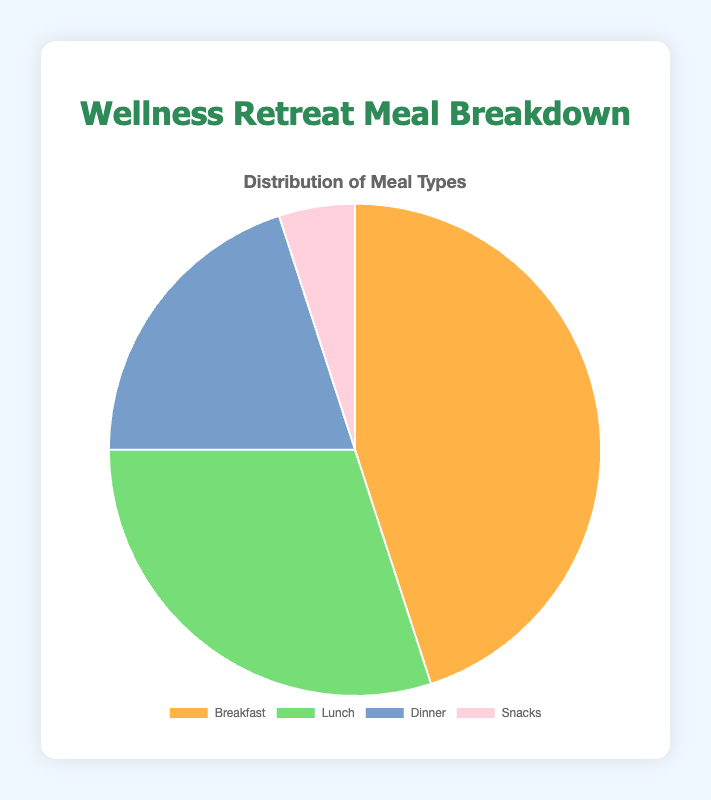What percentage of meals served are either for lunch or dinner? To find this, add the counts for Lunch (30) and Dinner (20), making 50. The total number of meals is 100. Therefore, the percentage is (50/100) * 100 = 50%.
Answer: 50% Which meal type is served the most frequently? The pie chart indicates that Breakfast has the highest count, which is 45. Comparing the numbers, Breakfast is the highest among all meal types.
Answer: Breakfast How many more breakfast meals are served compared to snack meals? The count for Breakfast is 45 and for Snacks is 5. Subtracting these: 45 - 5 = 40.
Answer: 40 What is the ratio of breakfast meals to dinner meals? The count for Breakfast is 45 and for Dinner is 20. The ratio is 45:20 or simplified to 9:4.
Answer: 9:4 Which meal type makes up exactly one-fifth of the total meals served? One-fifth of the total meals (100) is 20. The count for Dinner precisely matches this value, so Dinner makes up one-fifth of the total meals.
Answer: Dinner What is the combined percentage of breakfast and snacks? Adding the counts for Breakfast (45) and Snacks (5) gives 50. The total number of meals is 100, so the percentage is (50/100) * 100 = 50%.
Answer: 50% Which color in the pie chart represents lunch meals? Observing the provided visual descriptions, Lunch is represented by Pastel Green.
Answer: Pastel Green By how much does the percentage of breakfast exceed the percentage of lunch? The percentage for Breakfast is (45/100) * 100 = 45%, and for Lunch, it's (30/100) * 100 = 30%. The difference is 45% - 30% = 15%.
Answer: 15% If the number of snack meals doubled, what would be the new percentage for snacks? Doubling the count for Snacks gives 5 * 2 = 10. The new total number of meals would be 105 (100 + 5 extra). The percentage for Snacks then becomes (10/105) * 100 ≈ 9.52%.
Answer: 9.52% What proportion of meals served are not breakfast or lunch? The counts for Breakfast and Lunch are 45 and 30, respectively, giving a combined total of 75. The total number of meals is 100, so the portion that is not Breakfast or Lunch is 25 (100 - 75). The proportion is 25%.
Answer: 25% 